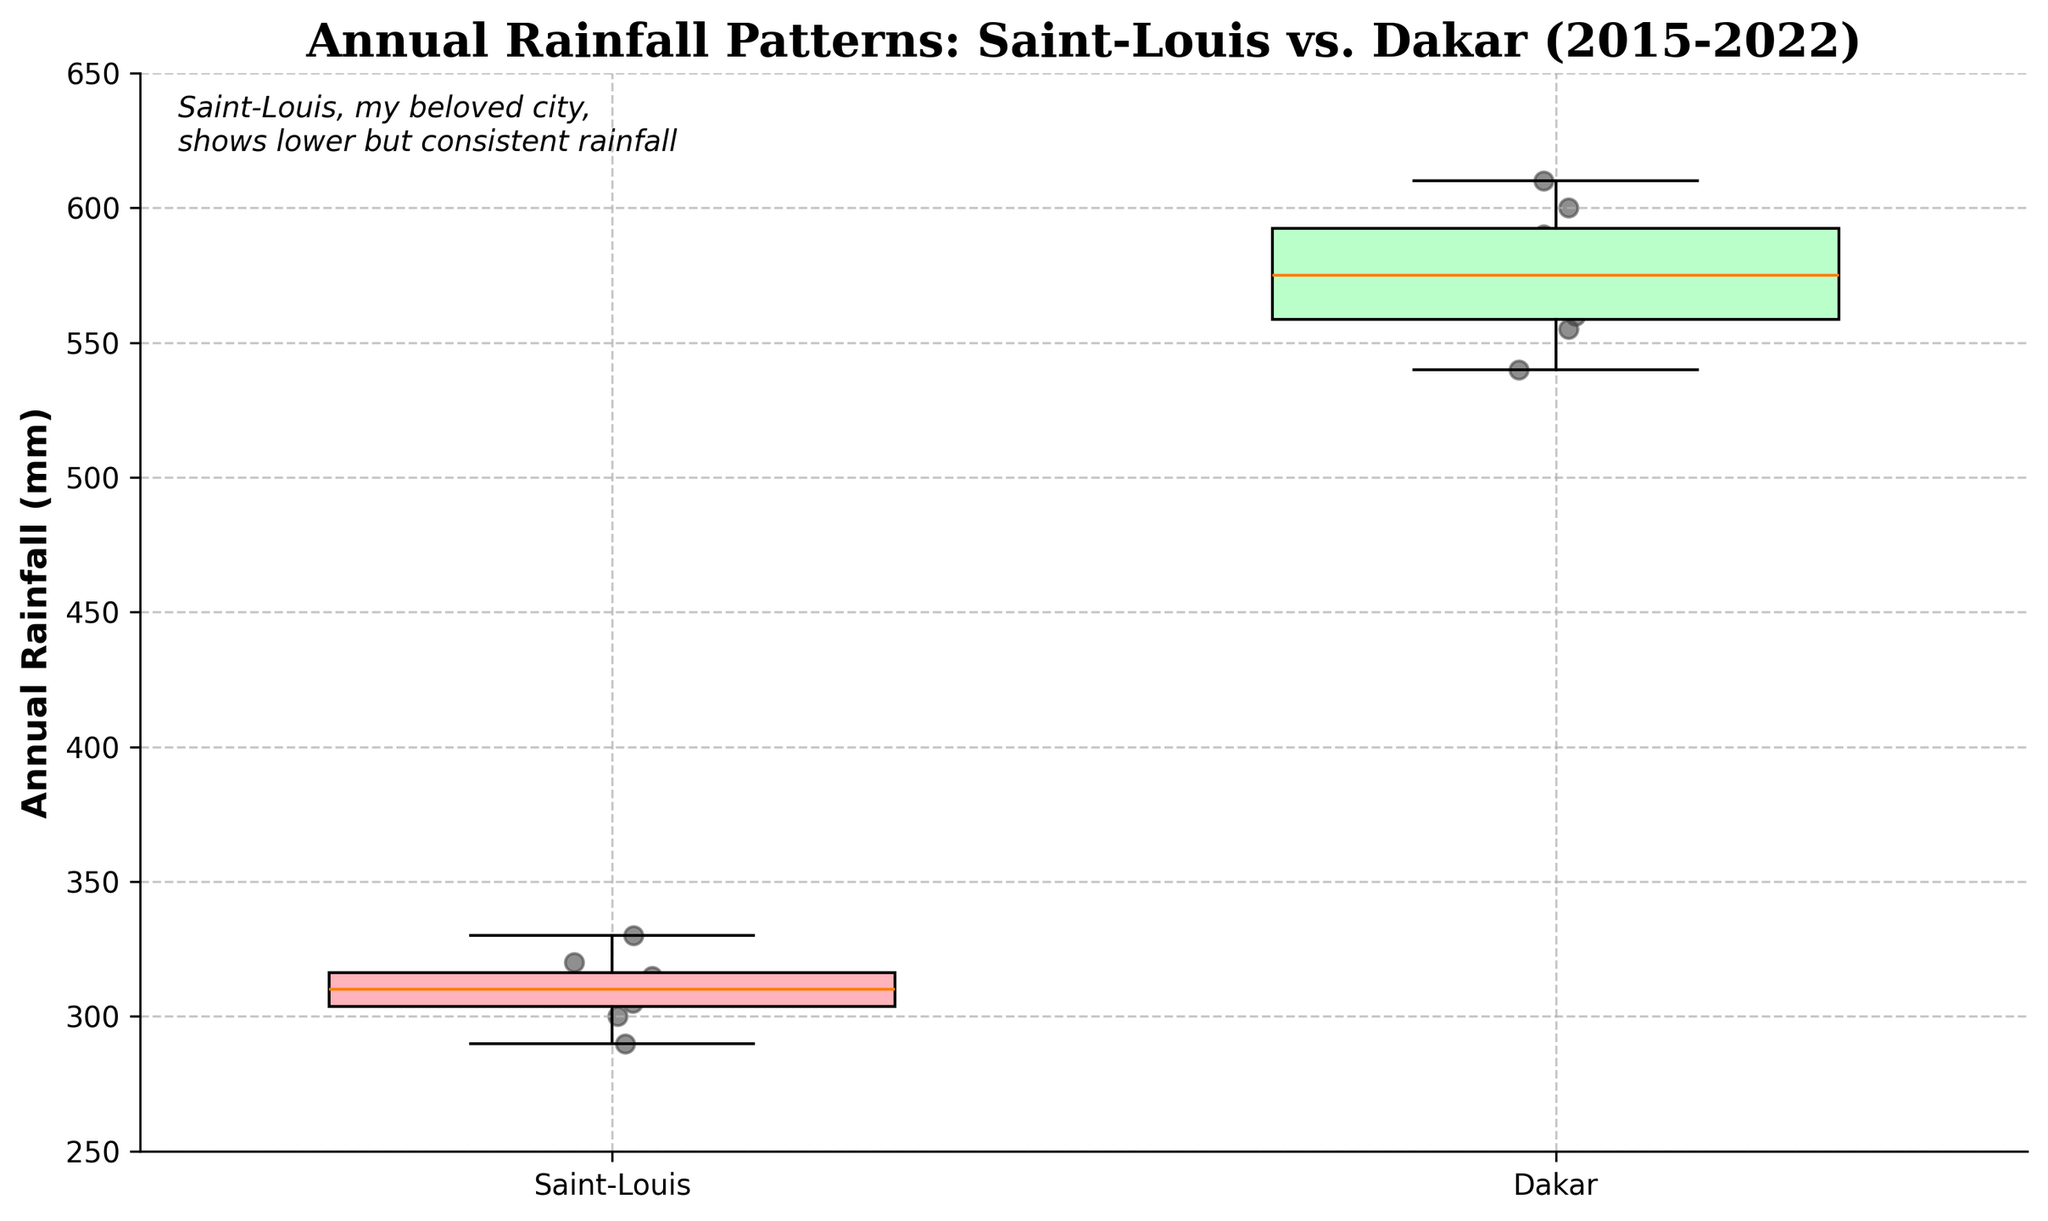What is the title of the plot? The title of the plot is located at the top of the figure.
Answer: Annual Rainfall Patterns: Saint-Louis vs. Dakar (2015-2022) Which city has a consistently higher annual rainfall, Saint-Louis or Dakar? By comparing the two box plots, it is evident that Dakar's median, quartiles, and overall range of annual rainfall values are consistently higher than those of Saint-Louis.
Answer: Dakar How many years of data are shown in the plot? The plot includes data points for each year represented by scattered dots within the box plots. Counting the dots for one city (either Saint-Louis or Dakar) reveals the total number of years.
Answer: 8 years What is the range of the y-axis values? The range of the y-axis can be determined by looking at the minimum and maximum values on the vertical axis.
Answer: 250 to 650 mm Which city’s annual rainfall has the highest variability? Higher variability in annual rainfall is indicated by a larger interquartile range and longer whiskers in the box plot. The box plot for Dakar shows larger interquartile range and longer whiskers compared to Saint-Louis.
Answer: Dakar What is the median annual rainfall for Saint-Louis? The median value for a box plot is indicated by the line inside the box. For Saint-Louis, look for this line within its box plot.
Answer: Approximately 310 mm What is the median annual rainfall for Dakar? The median value for a box plot is indicated by the line inside the box. For Dakar, look for this line within its box plot.
Answer: Approximately 570 mm Which city has more consistent annual rainfall, Saint-Louis or Dakar? Consistency in annual rainfall can be assessed by comparing the spread or variability in the box plots. Saint-Louis has a narrower interquartile range and shorter whiskers, indicating more consistent annual rainfall than Dakar.
Answer: Saint-Louis Is there any trend observable in Saint-Louis' annual rainfall data points over the years depicted in the plot? Observing the scatter points for Saint-Louis, there is a slight increase in values, but the plot mainly shows consistency rather than a clear increasing or decreasing trend.
Answer: No clear trend Do both cities exhibit any years with notably higher or lower rainfall compared to others? Look at the scatter points to identify any outliers or years with extreme values. Both cities have points that are closer to the upper and lower extremes of the y-axis, indicating some variability in annual rainfall.
Answer: Yes 